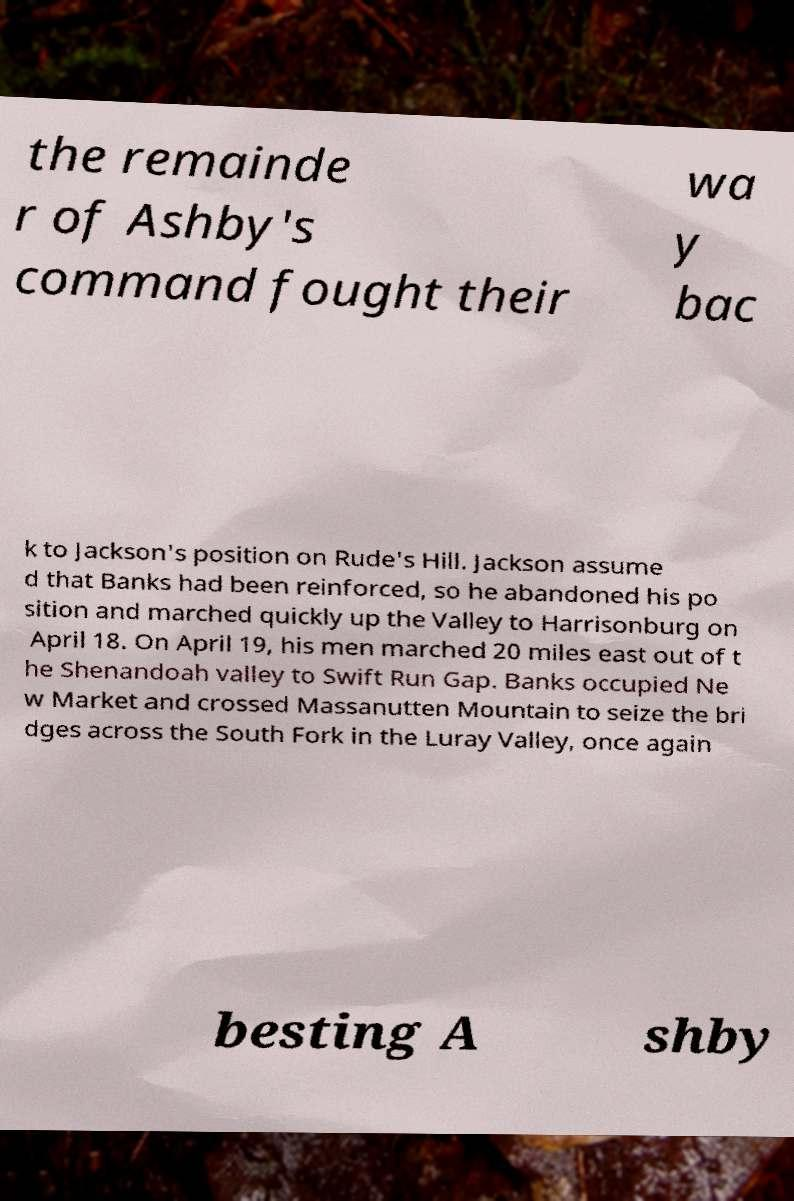What messages or text are displayed in this image? I need them in a readable, typed format. the remainde r of Ashby's command fought their wa y bac k to Jackson's position on Rude's Hill. Jackson assume d that Banks had been reinforced, so he abandoned his po sition and marched quickly up the Valley to Harrisonburg on April 18. On April 19, his men marched 20 miles east out of t he Shenandoah valley to Swift Run Gap. Banks occupied Ne w Market and crossed Massanutten Mountain to seize the bri dges across the South Fork in the Luray Valley, once again besting A shby 